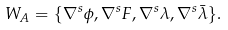<formula> <loc_0><loc_0><loc_500><loc_500>W _ { A } = \{ \nabla ^ { s } \phi , \nabla ^ { s } F , \nabla ^ { s } \lambda , \nabla ^ { s } \bar { \lambda } \} .</formula> 